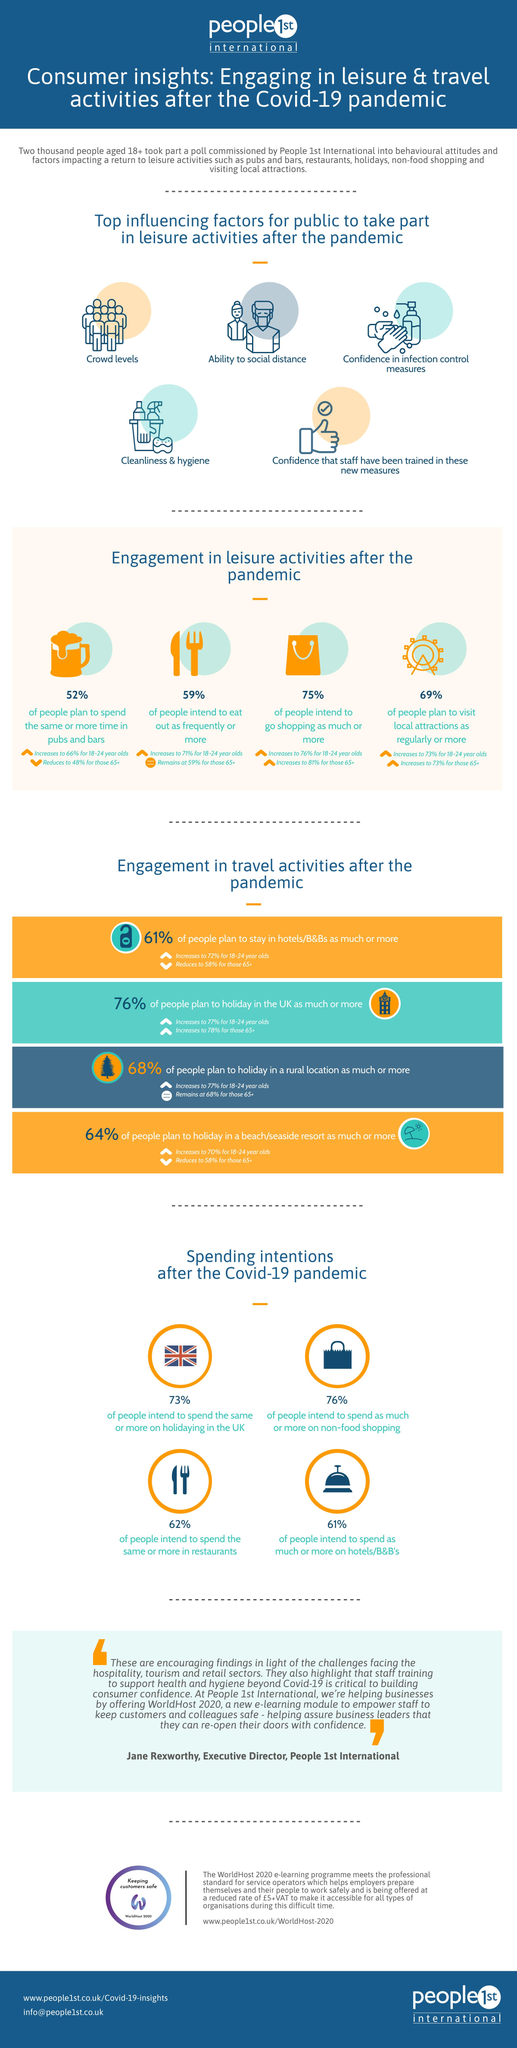Draw attention to some important aspects in this diagram. According to a recent survey, a staggering 76% of people in the UK intend to increase their spending on non-food items after the COVID-19 pandemic. This is a clear indication of the resilience of the consumer market and the confidence people have in their economic future. According to a recent survey, 62% of people in the U.K. intend to spend the same or more on restaurants after the COVID-19 pandemic. According to a recent survey, 69% of people in the U.K. plan to visit local attractions on a regular or more frequent basis after the Covid-19 pandemic. According to a recent survey, it is estimated that 75% of people in the U.K. intend to go shopping again after the Covid-19 pandemic. According to a recent survey, it is estimated that 59% of people in the United Kingdom intend to eat out more frequently after the COVID-19 pandemic. 